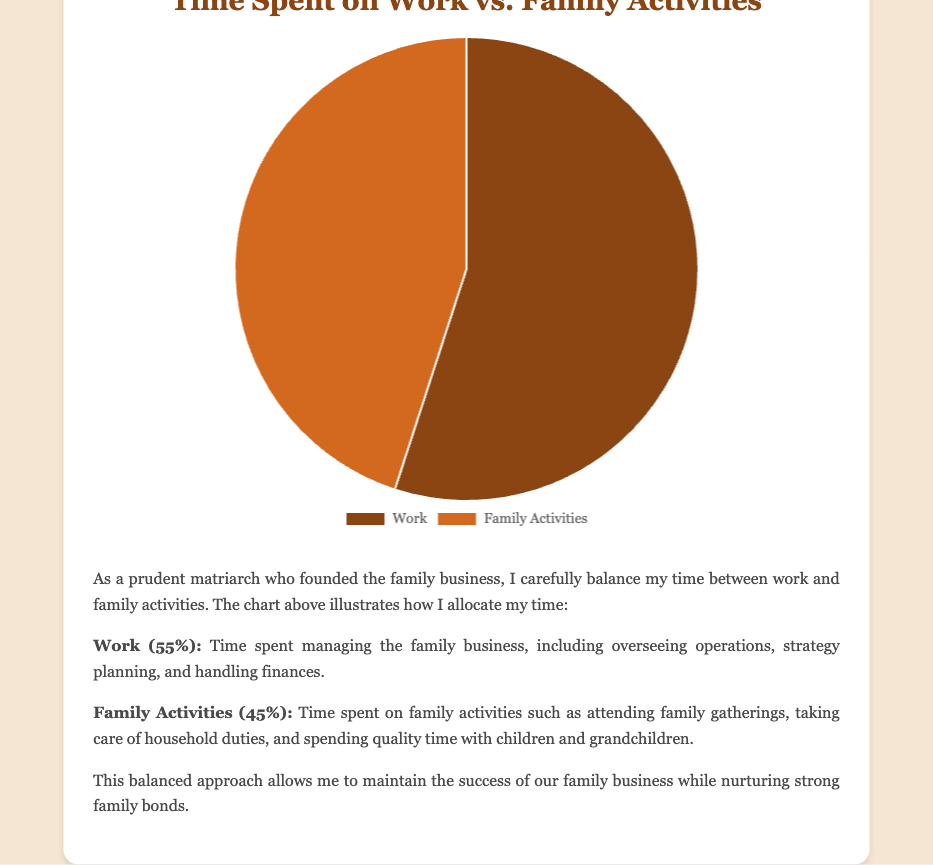Which activity takes up more time, Work or Family Activities? By looking at the pie chart, we can see that Work occupies a larger portion of the chart compared to Family Activities. Thus, Work takes up more time.
Answer: Work What is the percentage of time spent on Family Activities? The pie chart shows a data point labeled "Family Activities," which occupies 45% of the chart.
Answer: 45% How much more time is spent on Work compared to Family Activities? Work takes 55% and Family Activities take 45%. To find out how much more time is spent on Work, we subtract the percentage allocated to Family Activities from the percentage allocated to Work: 55% - 45% = 10%.
Answer: 10% What fraction of the total time is spent on Work? The pie chart shows that Work occupies 55% of the total time. To convert this percentage to a fraction, we divide 55 by 100: 55/100 = 11/20.
Answer: 11/20 Is the time spent on Family Activities less than half of the total time? Family Activities account for 45% of the total time. Half of the total time is 50%. Since 45% is less than 50%, the time spent on Family Activities is indeed less than half.
Answer: Yes If six additional hours were added to Family Activities, what would the new percentage be for Family Activities (assuming the total time increases proportionally)? Current distribution: Work 55%, Family Activities 45%. First, determine the total time: if Family Activities are initially represented by 45%, then Work + Family = 55 + 45 = 100%. If 6 additional hours are added to Family Activities, the new sum of hours will be greater. Suppose "x" is the total hours, then 45% of x = Family Activities hours. New Family Activities hours = 45% of x + 6. New total time = x + 6. Thus, the new percentage would be {[(0.45x + 6)/(x + 6)] * 100}. Specifying "x" will yield the exact figure, but it needs algebraic simplification for exact calculation.
Answer: Complex calculation needed What color represents Work in the pie chart? The pie chart uses distinct colors to represent different activities, and Work is represented by a brownish color.
Answer: Brown If you combine the time spent on Work and Family Activities, what is the overall total time in percentage terms? In a pie chart, the percentages for all categories should sum to 100%. Thus, combining Work (55%) and Family Activities (45%) gives 55% + 45% = 100%.
Answer: 100% What is the difference of time spent between Work and Family Activities in terms of percentage? Subtract the percentage value assigned to Family Activities from the percentage value assigned to Work: 55% - 45% = 10%. Thus, the difference in time spent is 10%.
Answer: 10% Based on visual observation, which segment of the pie chart is visually smaller? By observing the pie chart, the segment for Family Activities appears visually smaller than the segment for Work.
Answer: Family Activities 